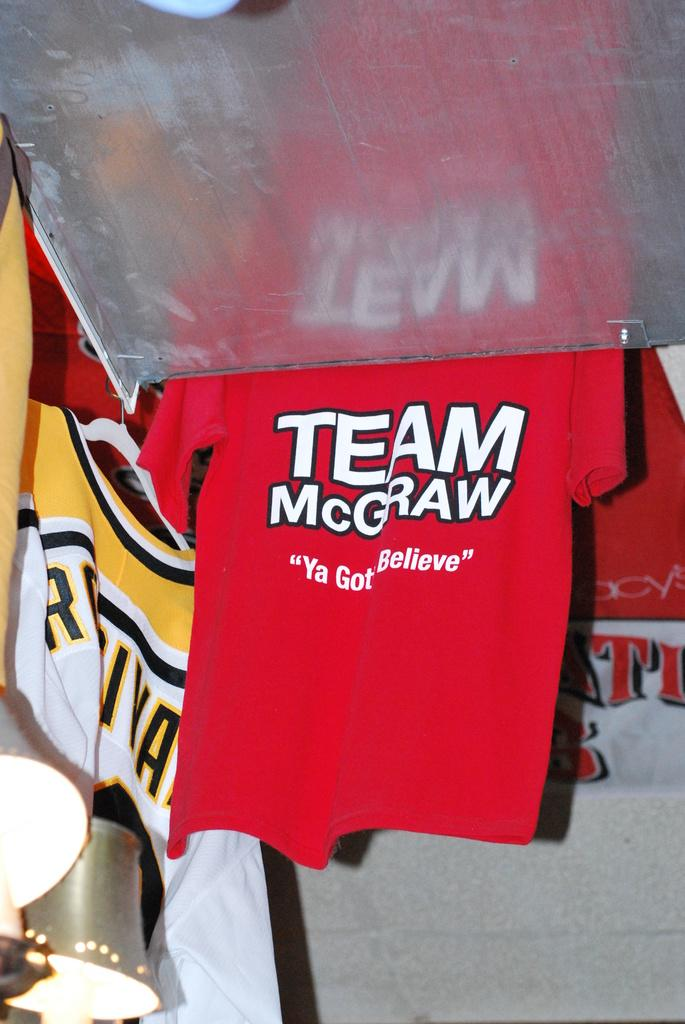Provide a one-sentence caption for the provided image. A shirt advertising Team McGraw hangs up next to a metal plate. 